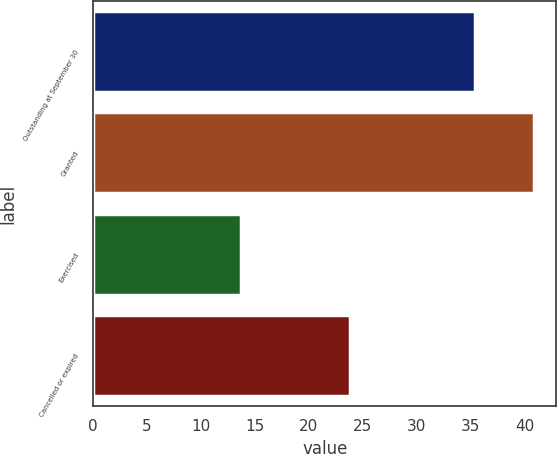Convert chart. <chart><loc_0><loc_0><loc_500><loc_500><bar_chart><fcel>Outstanding at September 30<fcel>Granted<fcel>Exercised<fcel>Cancelled or expired<nl><fcel>35.45<fcel>40.92<fcel>13.69<fcel>23.84<nl></chart> 